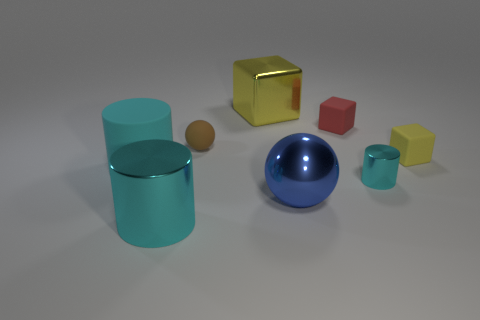How many other objects are there of the same size as the cyan matte thing?
Ensure brevity in your answer.  3. What material is the yellow cube that is to the left of the yellow block that is in front of the metallic thing behind the red block?
Provide a short and direct response. Metal. There is a big cylinder that is the same color as the large matte thing; what is its material?
Your answer should be compact. Metal. How many spheres are the same material as the small cyan thing?
Offer a terse response. 1. Does the metallic cylinder on the left side of the brown matte object have the same size as the big cyan matte object?
Your answer should be very brief. Yes. What is the color of the block that is the same material as the tiny yellow object?
Make the answer very short. Red. There is a red matte cube; how many matte cylinders are on the right side of it?
Your answer should be very brief. 0. Is the color of the metallic cylinder on the right side of the shiny cube the same as the metallic cylinder that is on the left side of the small red block?
Provide a succinct answer. Yes. The small matte object that is the same shape as the large blue shiny object is what color?
Offer a very short reply. Brown. There is a large cyan thing that is behind the big blue object; is its shape the same as the shiny object behind the small red thing?
Make the answer very short. No. 